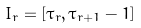Convert formula to latex. <formula><loc_0><loc_0><loc_500><loc_500>I _ { r } = [ \tau _ { r } , \tau _ { r + 1 } - 1 ]</formula> 